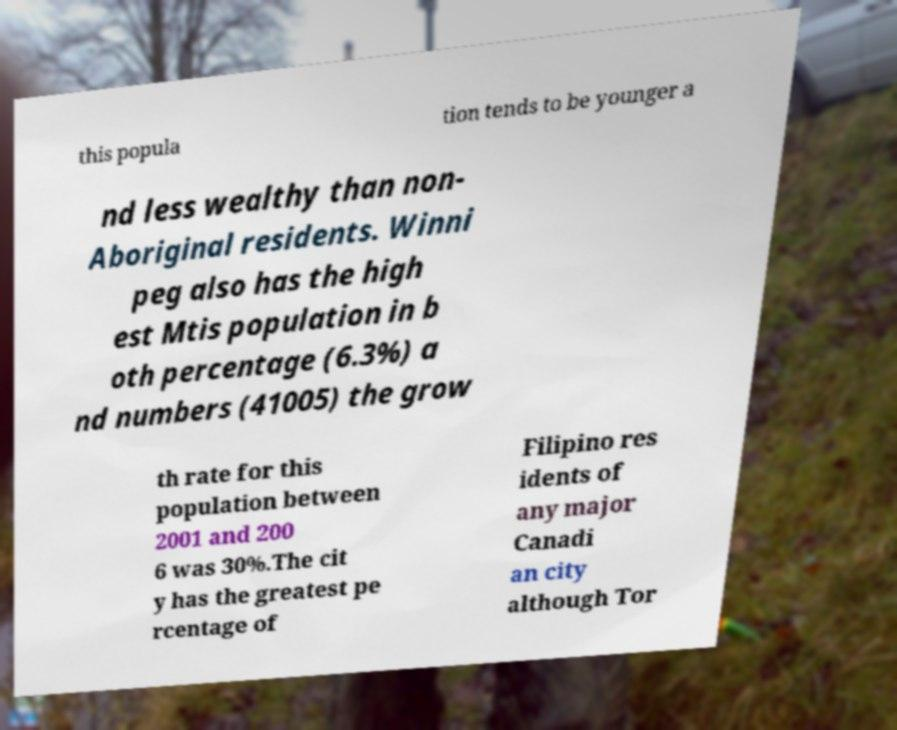For documentation purposes, I need the text within this image transcribed. Could you provide that? this popula tion tends to be younger a nd less wealthy than non- Aboriginal residents. Winni peg also has the high est Mtis population in b oth percentage (6.3%) a nd numbers (41005) the grow th rate for this population between 2001 and 200 6 was 30%.The cit y has the greatest pe rcentage of Filipino res idents of any major Canadi an city although Tor 